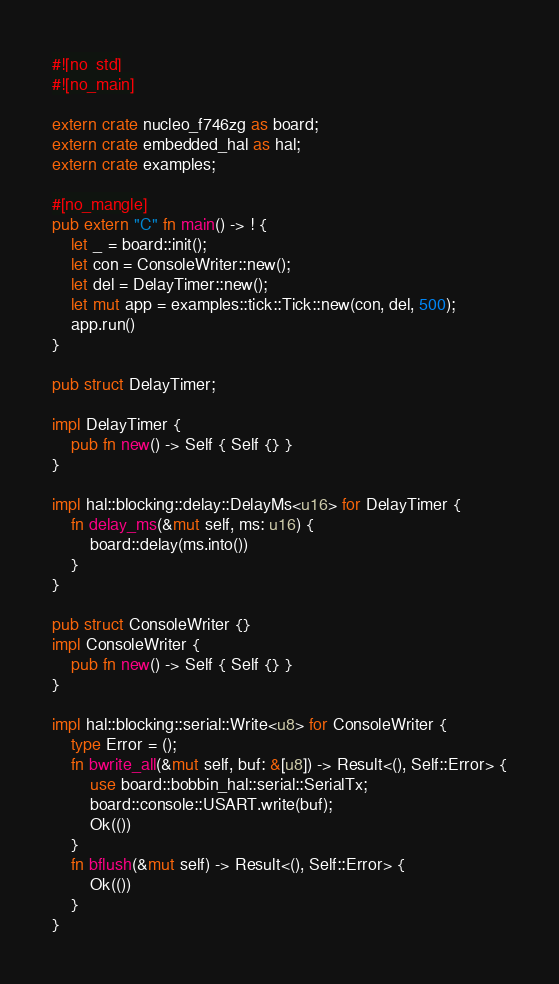<code> <loc_0><loc_0><loc_500><loc_500><_Rust_>#![no_std]
#![no_main]

extern crate nucleo_f746zg as board;
extern crate embedded_hal as hal;
extern crate examples;

#[no_mangle]
pub extern "C" fn main() -> ! {
    let _ = board::init();    
    let con = ConsoleWriter::new();
    let del = DelayTimer::new();
    let mut app = examples::tick::Tick::new(con, del, 500);
    app.run()
}

pub struct DelayTimer;

impl DelayTimer {
    pub fn new() -> Self { Self {} }
}

impl hal::blocking::delay::DelayMs<u16> for DelayTimer {
    fn delay_ms(&mut self, ms: u16) {
        board::delay(ms.into())
    }
}

pub struct ConsoleWriter {}
impl ConsoleWriter {
    pub fn new() -> Self { Self {} }
}

impl hal::blocking::serial::Write<u8> for ConsoleWriter {
    type Error = ();
    fn bwrite_all(&mut self, buf: &[u8]) -> Result<(), Self::Error> {
        use board::bobbin_hal::serial::SerialTx;
        board::console::USART.write(buf);
        Ok(())
    }
    fn bflush(&mut self) -> Result<(), Self::Error> {
        Ok(())
    }
}</code> 